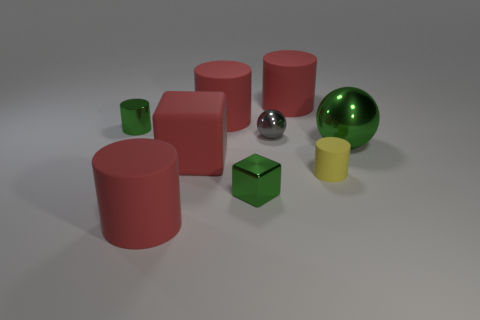What is the big block made of?
Your response must be concise. Rubber. Do the small green cylinder and the tiny cylinder in front of the tiny green cylinder have the same material?
Provide a short and direct response. No. How many things are either balls in front of the gray object or tiny green blocks?
Your answer should be very brief. 2. What is the size of the green metal block to the left of the small cylinder to the right of the large red cylinder in front of the large sphere?
Keep it short and to the point. Small. There is a small cylinder that is the same color as the big metallic thing; what is its material?
Your response must be concise. Metal. What is the size of the cylinder that is to the right of the red thing that is on the right side of the green cube?
Provide a short and direct response. Small. What number of large objects are either gray spheres or red blocks?
Your answer should be very brief. 1. Are there fewer small matte cylinders than tiny cyan rubber balls?
Ensure brevity in your answer.  No. Is the color of the metal cube the same as the big ball?
Ensure brevity in your answer.  Yes. Is the number of matte things greater than the number of things?
Your response must be concise. No. 